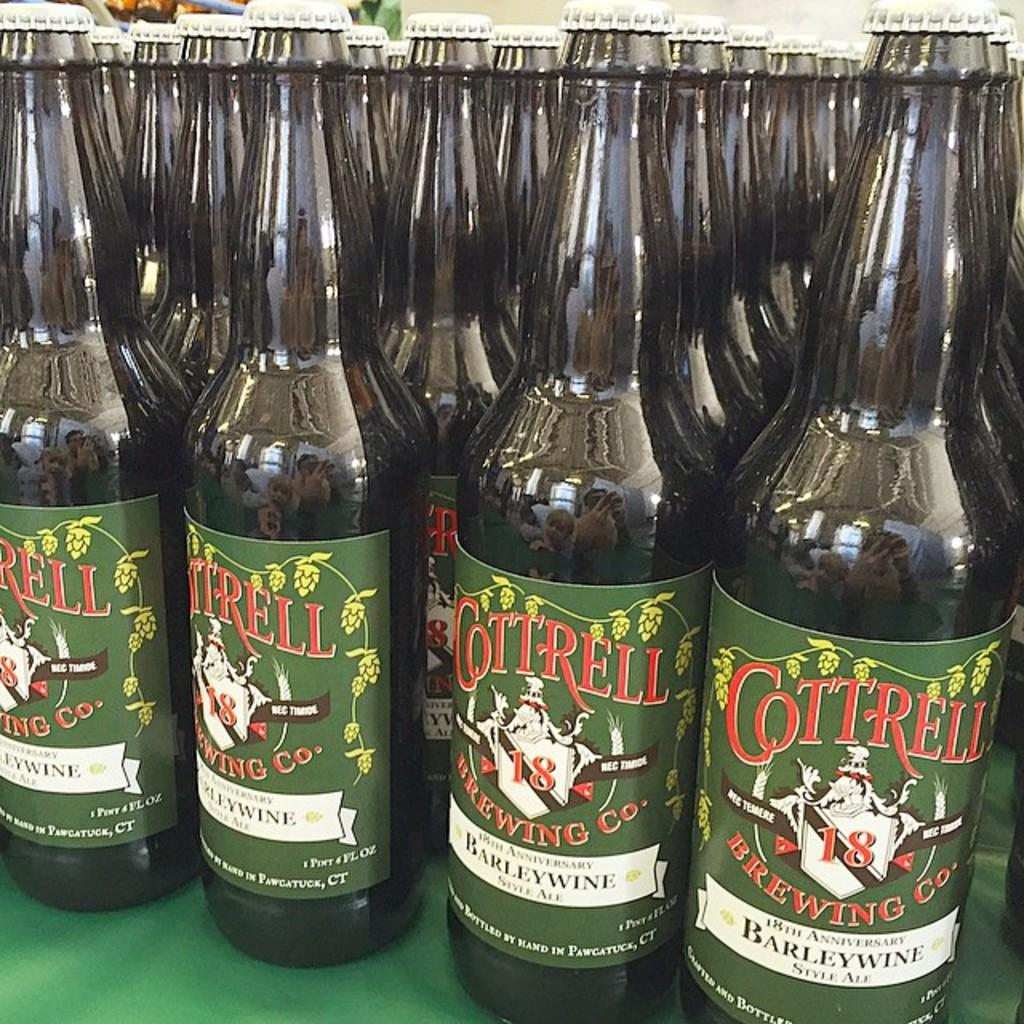<image>
Render a clear and concise summary of the photo. Several bottles of Cottrell beer are on a green table. 